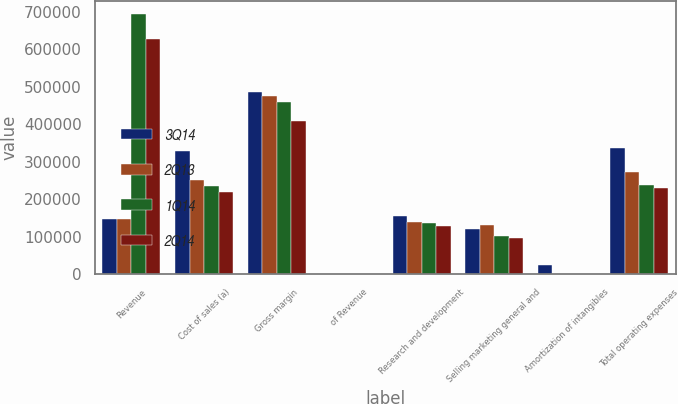Convert chart to OTSL. <chart><loc_0><loc_0><loc_500><loc_500><stacked_bar_chart><ecel><fcel>Revenue<fcel>Cost of sales (a)<fcel>Gross margin<fcel>of Revenue<fcel>Research and development<fcel>Selling marketing general and<fcel>Amortization of intangibles<fcel>Total operating expenses<nl><fcel>3Q14<fcel>147446<fcel>328210<fcel>486037<fcel>59.7<fcel>154797<fcel>121424<fcel>25250<fcel>336108<nl><fcel>2Q13<fcel>147446<fcel>251462<fcel>476290<fcel>65.4<fcel>140095<fcel>132989<fcel>660<fcel>273744<nl><fcel>1Q14<fcel>694536<fcel>235793<fcel>458743<fcel>66.1<fcel>136203<fcel>102085<fcel>55<fcel>238343<nl><fcel>2Q14<fcel>628238<fcel>219120<fcel>409118<fcel>65.1<fcel>128591<fcel>98178<fcel>55<fcel>229509<nl></chart> 